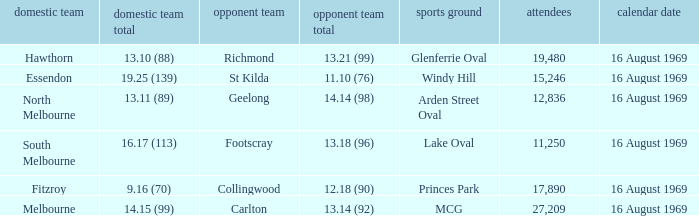When was the game played at Lake Oval? 16 August 1969. 